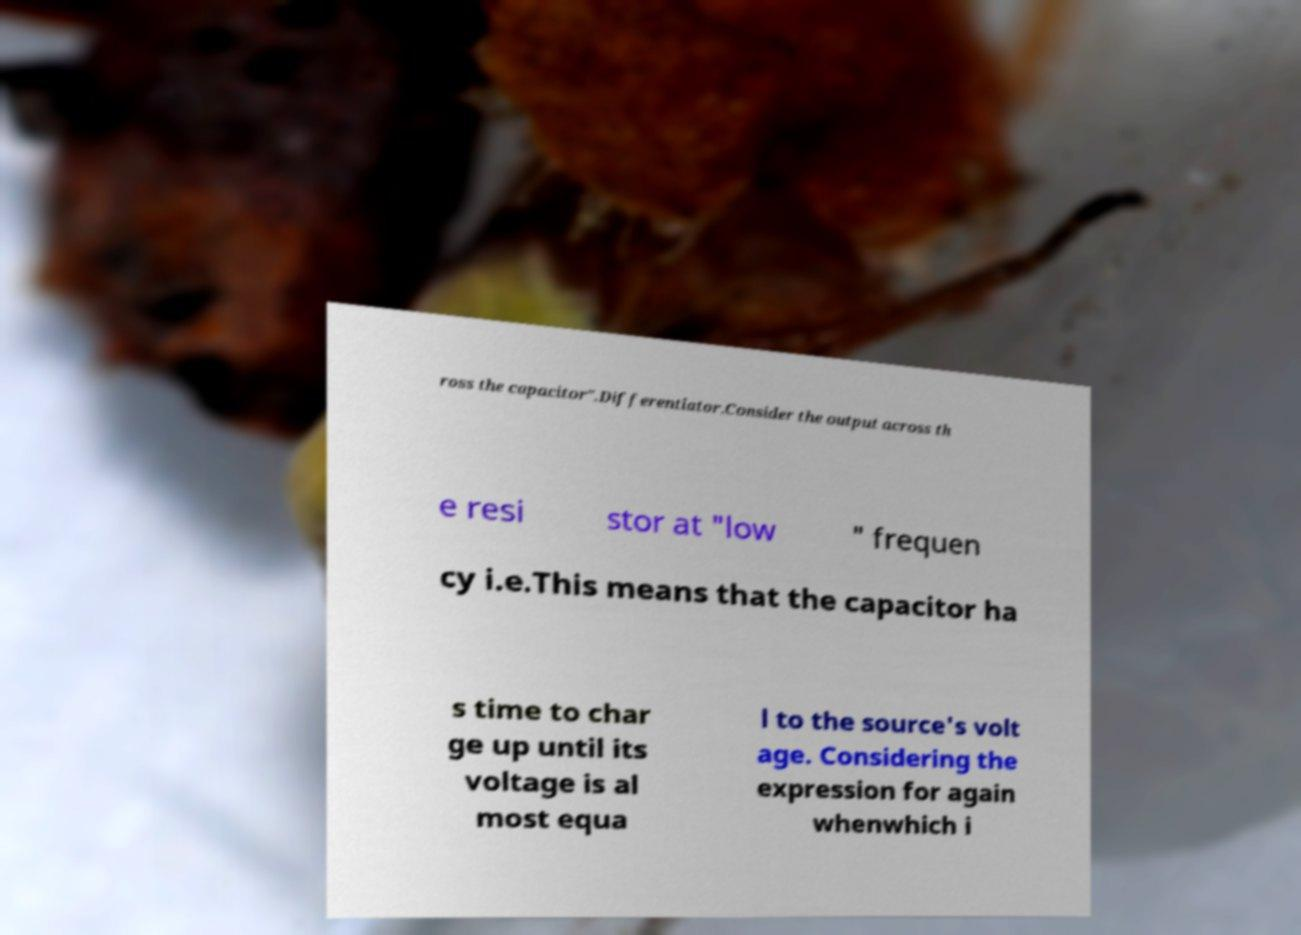Please read and relay the text visible in this image. What does it say? ross the capacitor".Differentiator.Consider the output across th e resi stor at "low " frequen cy i.e.This means that the capacitor ha s time to char ge up until its voltage is al most equa l to the source's volt age. Considering the expression for again whenwhich i 